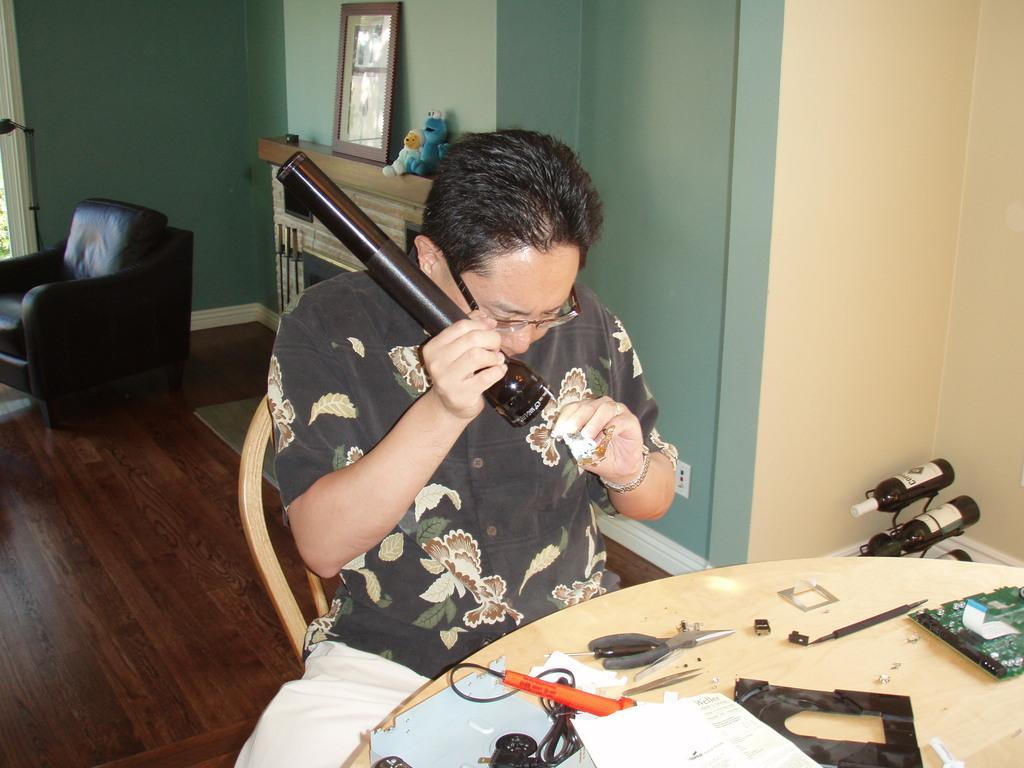Please provide a concise description of this image. In the image we can see there is a man who is sitting and holding a torch in his hand and on table there are electrical equipments and there are wine bottles in the bottle stand and at the back there is black colour chair and on table there are toys and photo frame. 